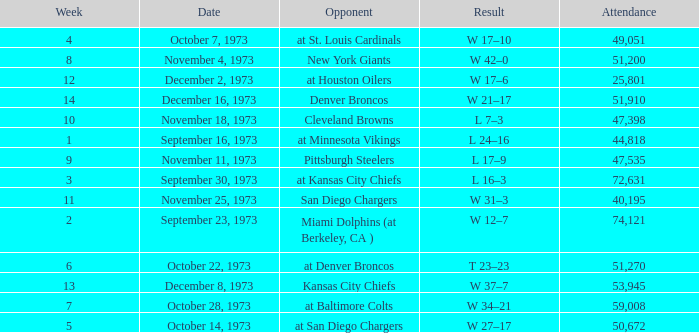I'm looking to parse the entire table for insights. Could you assist me with that? {'header': ['Week', 'Date', 'Opponent', 'Result', 'Attendance'], 'rows': [['4', 'October 7, 1973', 'at St. Louis Cardinals', 'W 17–10', '49,051'], ['8', 'November 4, 1973', 'New York Giants', 'W 42–0', '51,200'], ['12', 'December 2, 1973', 'at Houston Oilers', 'W 17–6', '25,801'], ['14', 'December 16, 1973', 'Denver Broncos', 'W 21–17', '51,910'], ['10', 'November 18, 1973', 'Cleveland Browns', 'L 7–3', '47,398'], ['1', 'September 16, 1973', 'at Minnesota Vikings', 'L 24–16', '44,818'], ['9', 'November 11, 1973', 'Pittsburgh Steelers', 'L 17–9', '47,535'], ['3', 'September 30, 1973', 'at Kansas City Chiefs', 'L 16–3', '72,631'], ['11', 'November 25, 1973', 'San Diego Chargers', 'W 31–3', '40,195'], ['2', 'September 23, 1973', 'Miami Dolphins (at Berkeley, CA )', 'W 12–7', '74,121'], ['6', 'October 22, 1973', 'at Denver Broncos', 'T 23–23', '51,270'], ['13', 'December 8, 1973', 'Kansas City Chiefs', 'W 37–7', '53,945'], ['7', 'October 28, 1973', 'at Baltimore Colts', 'W 34–21', '59,008'], ['5', 'October 14, 1973', 'at San Diego Chargers', 'W 27–17', '50,672']]} What is the highest number in attendance against the game at Kansas City Chiefs? 72631.0. 